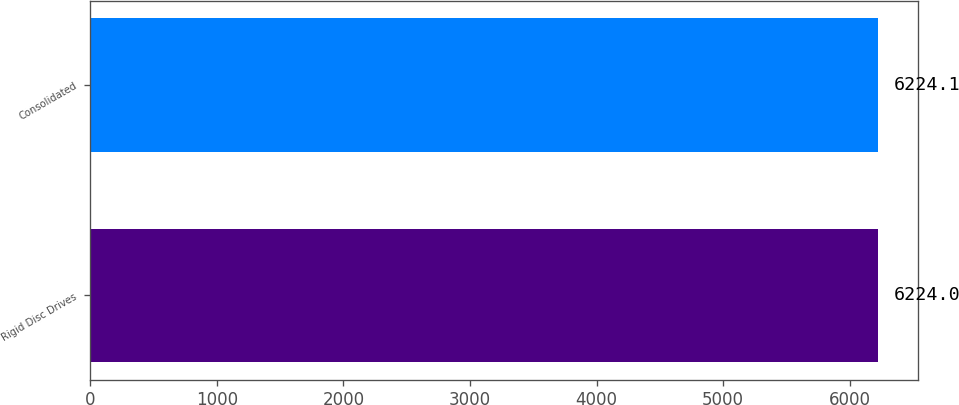<chart> <loc_0><loc_0><loc_500><loc_500><bar_chart><fcel>Rigid Disc Drives<fcel>Consolidated<nl><fcel>6224<fcel>6224.1<nl></chart> 